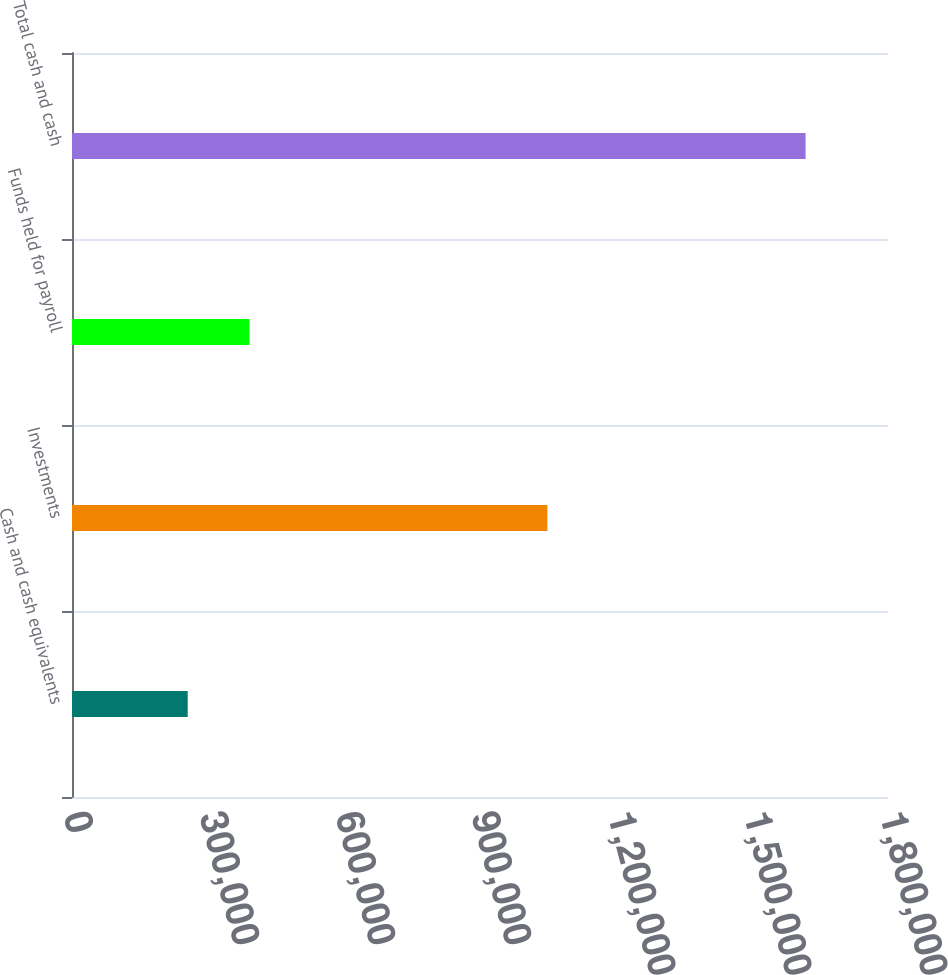Convert chart. <chart><loc_0><loc_0><loc_500><loc_500><bar_chart><fcel>Cash and cash equivalents<fcel>Investments<fcel>Funds held for payroll<fcel>Total cash and cash<nl><fcel>255201<fcel>1.04864e+06<fcel>391499<fcel>1.61818e+06<nl></chart> 